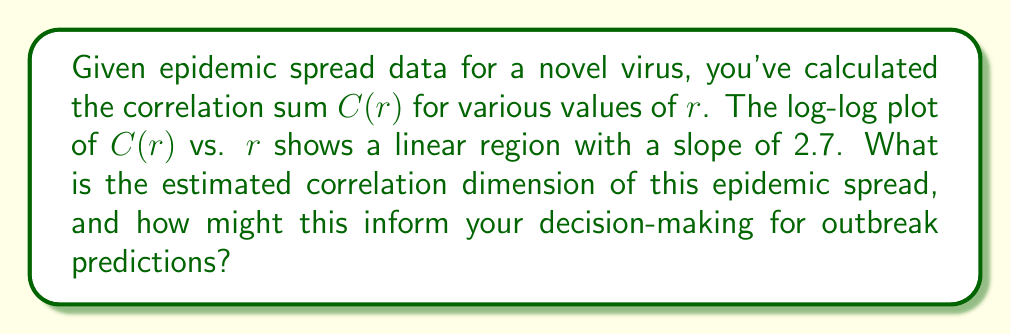Could you help me with this problem? To solve this problem, we'll follow these steps:

1) The correlation dimension $D_2$ is defined as the slope of the linear region in the log-log plot of $C(r)$ vs. $r$, where:

   $$D_2 = \lim_{r \to 0} \frac{\log C(r)}{\log r}$$

2) In practice, we estimate $D_2$ by calculating this slope for small values of $r$.

3) Given information: The slope of the linear region is 2.7.

4) Therefore, the estimated correlation dimension $D_2$ is 2.7.

5) Interpretation for decision-making:
   - The correlation dimension provides information about the complexity of the system.
   - A non-integer dimension (2.7) suggests that the epidemic spread exhibits fractal-like behavior, indicating a complex, chaotic system.
   - This complexity implies that the epidemic spread is sensitive to initial conditions and may be difficult to predict long-term.
   - However, it also suggests that the system has some underlying structure (not purely random), which can be leveraged for short-term predictions.
   - A dimension between 2 and 3 indicates that while the spread is more complex than a simple 2D model, it's not utilizing the full 3D space, which could inform containment strategies.

6) For outbreak predictions:
   - Use this information to develop more sophisticated models that account for the fractal nature of the spread.
   - Focus on short-term predictions and frequently update models with new data.
   - Consider implementing adaptive strategies that can quickly respond to changes in spread patterns.
   - Utilize this dimension in comparison with other outbreaks to gauge relative complexity and potential difficulty in containment.
Answer: $D_2 = 2.7$; indicates complex, chaotic spread requiring sophisticated, adaptive short-term prediction models. 